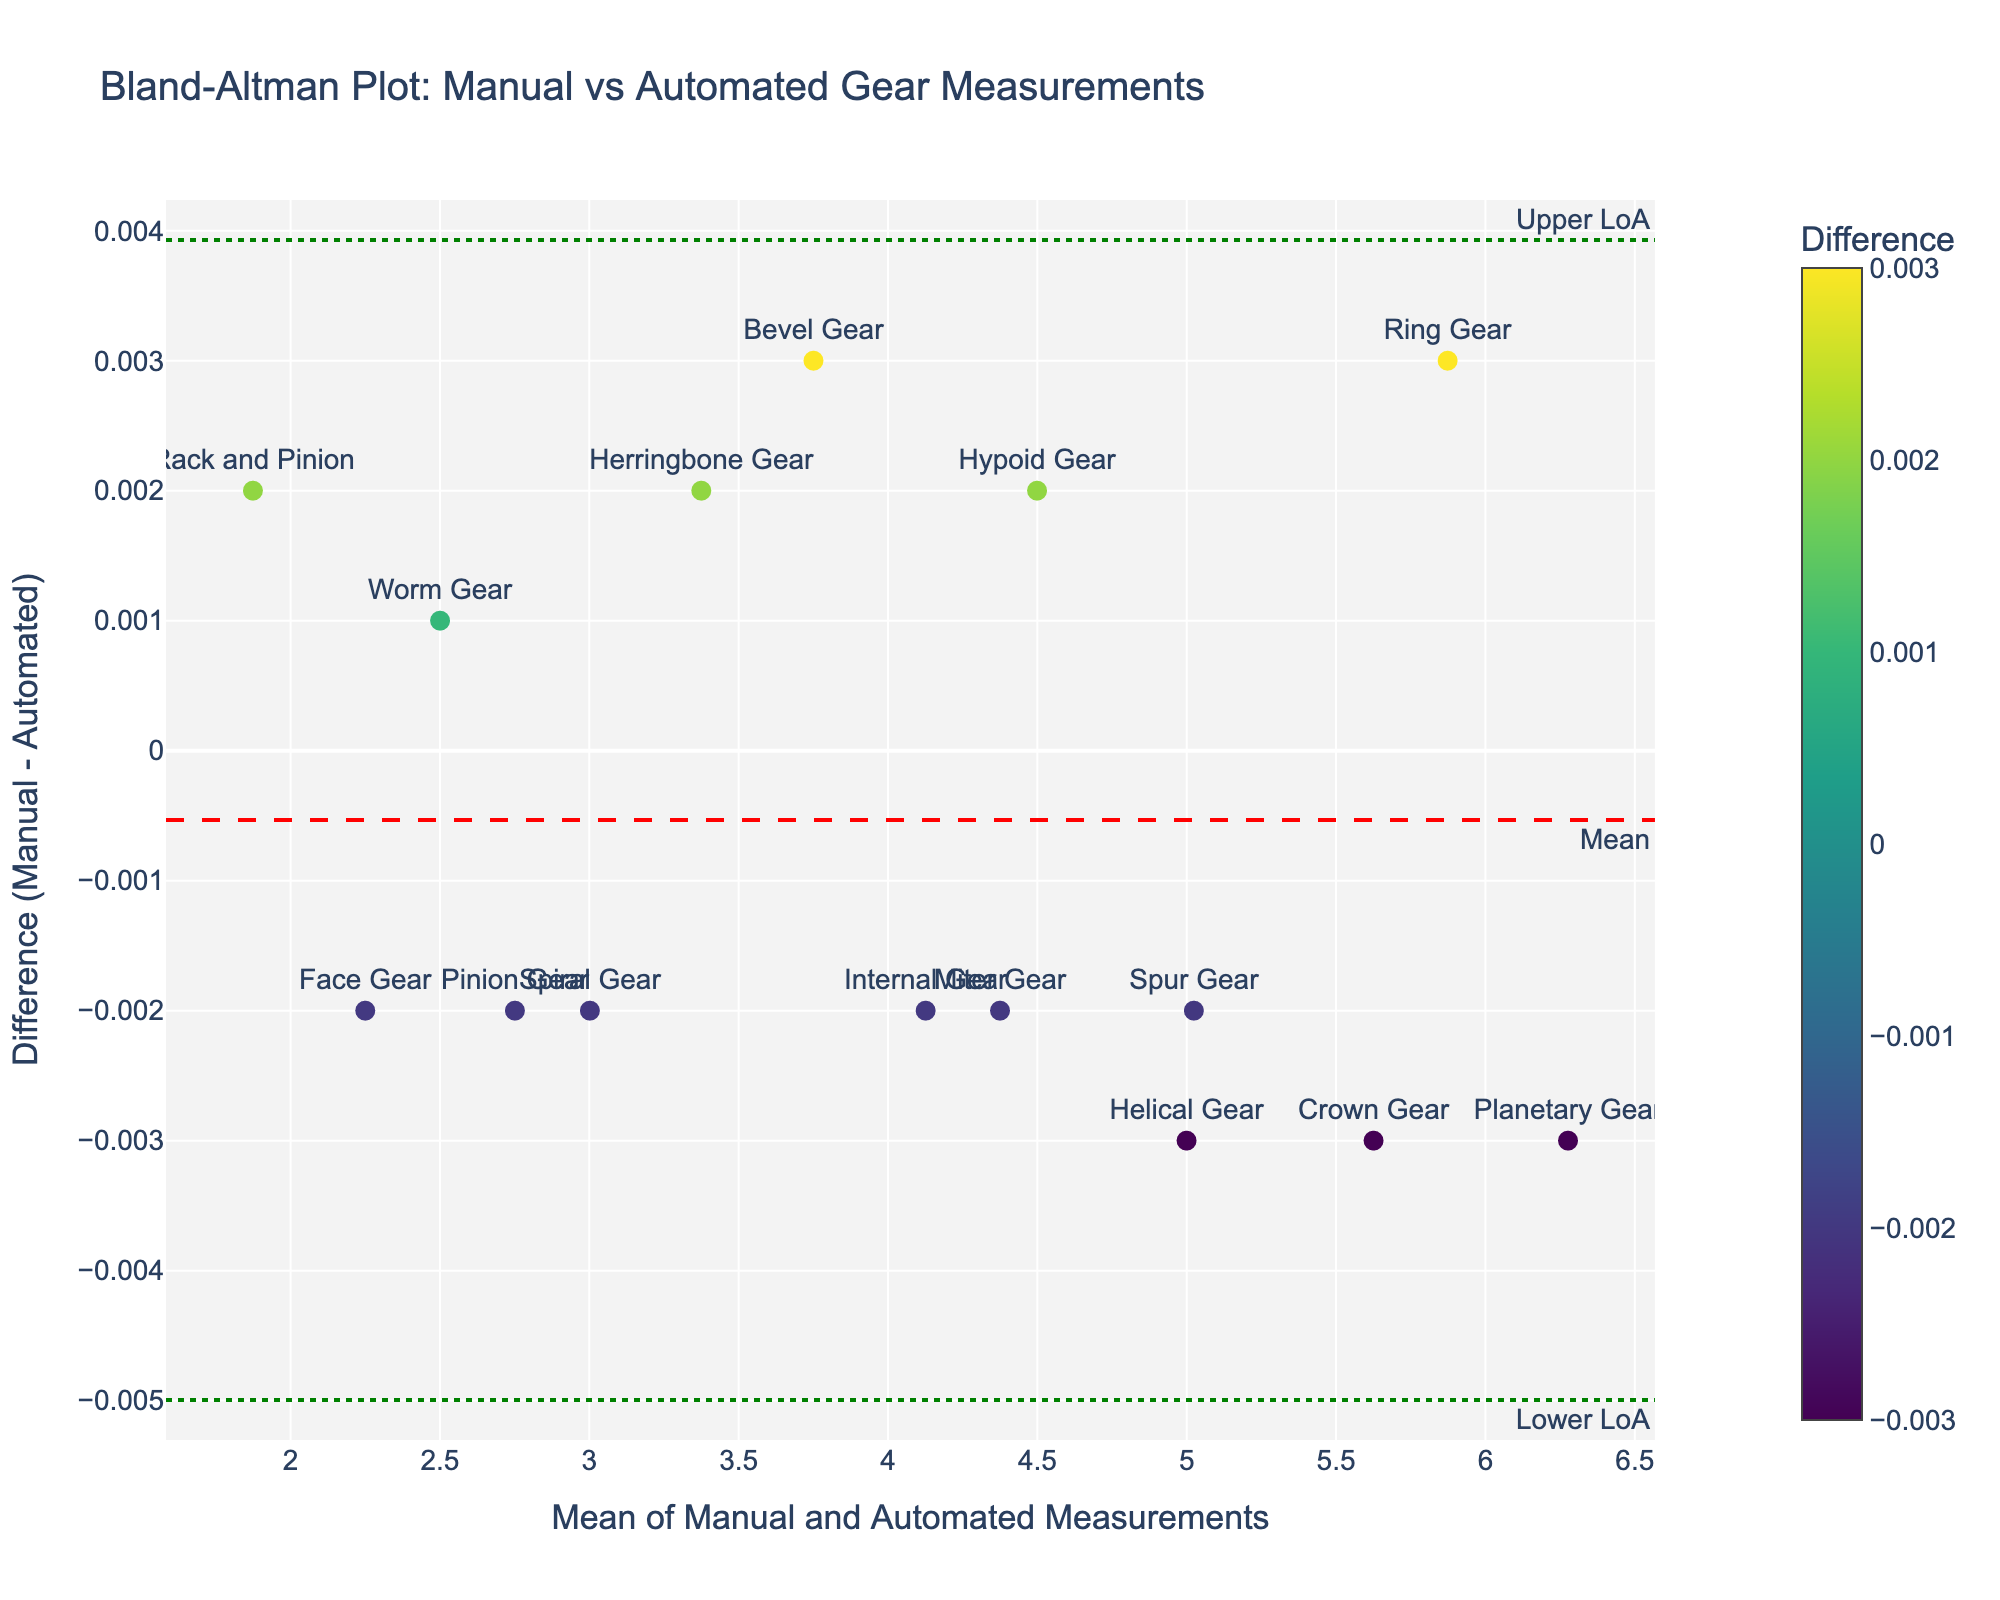What is the title of the plot? The title is clearly labeled at the top of the plot and reads "Bland-Altman Plot: Manual vs Automated Gear Measurements".
Answer: Bland-Altman Plot: Manual vs Automated Gear Measurements What do the x-axis and y-axis represent? The labels provided on the plot indicate that the x-axis represents the "Mean of Manual and Automated Measurements", while the y-axis shows the "Difference (Manual - Automated)" between the two measurements.
Answer: Mean of Manual and Automated Measurements, Difference (Manual - Automated) How many gear types are displayed in the plot? By counting the data points on the plot and referring to their labels, it is clear there are 15 different gear types displayed.
Answer: 15 What is the mean difference between manual and automated measurements? The plot features a horizontal dashed red line annotated with the text "Mean", indicating the mean difference. By visual inspection, this value can be observed close to the line's position on the y-axis.
Answer: ~0.000 Which gear type has the largest difference between manual and automated measurements? Observing the data points and their associated labels on the plot, the difference for the "Bevel Gear" appears to be the largest on the negative y-axis.
Answer: Bevel Gear What are the upper and lower limits of agreement? The plot features two horizontal green dashed lines labeled "Upper LoA" and "Lower LoA", indicating the upper and lower limits of agreement respectively. The y-axis values for these lines can be referred to directly.
Answer: Upper LoA: ~0.003, Lower LoA: ~-0.003 What is the mean of the manual and automated measurements for the Ring Gear? Identify the point labeled "Ring Gear" and check its x-axis value, as the x-axis represents the mean of the measurements.
Answer: ~5.874 Which gear type is closest to the mean difference line? By observing the data points, the "Spur Gear" appears to be the closest to the horizontal red dashed "Mean" line.
Answer: Spur Gear Between which values do the majority of differences fall? By visually assessing the spread of the data points between the "Upper LoA" and "Lower LoA" lines on the y-axis, one can determine the range that captures most differences.
Answer: -0.003 and 0.003 Is there any gear type whose difference falls outside the limits of agreement? By checking the data points to see if any fall outside the green dashed "Upper LoA" and "Lower LoA" lines, it appears all gear types' differences remain within these bounds.
Answer: No 